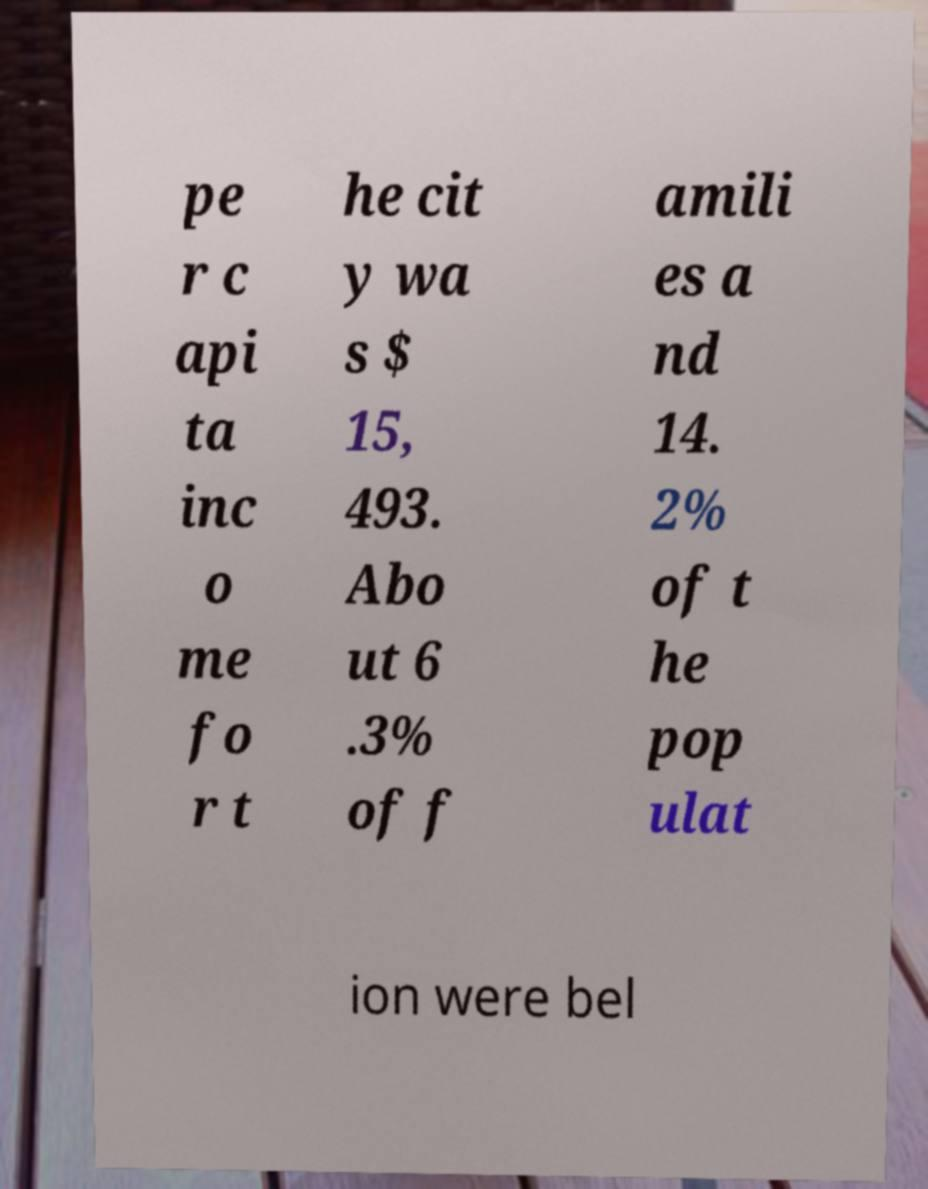For documentation purposes, I need the text within this image transcribed. Could you provide that? pe r c api ta inc o me fo r t he cit y wa s $ 15, 493. Abo ut 6 .3% of f amili es a nd 14. 2% of t he pop ulat ion were bel 